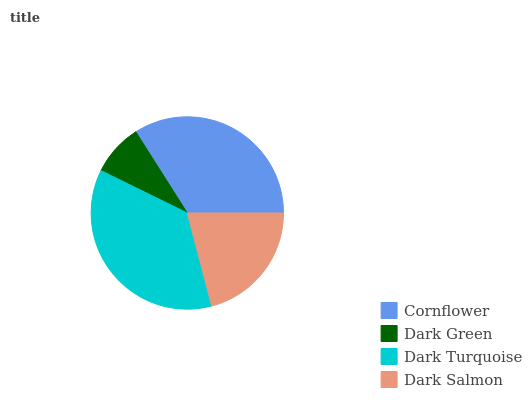Is Dark Green the minimum?
Answer yes or no. Yes. Is Dark Turquoise the maximum?
Answer yes or no. Yes. Is Dark Turquoise the minimum?
Answer yes or no. No. Is Dark Green the maximum?
Answer yes or no. No. Is Dark Turquoise greater than Dark Green?
Answer yes or no. Yes. Is Dark Green less than Dark Turquoise?
Answer yes or no. Yes. Is Dark Green greater than Dark Turquoise?
Answer yes or no. No. Is Dark Turquoise less than Dark Green?
Answer yes or no. No. Is Cornflower the high median?
Answer yes or no. Yes. Is Dark Salmon the low median?
Answer yes or no. Yes. Is Dark Green the high median?
Answer yes or no. No. Is Dark Turquoise the low median?
Answer yes or no. No. 